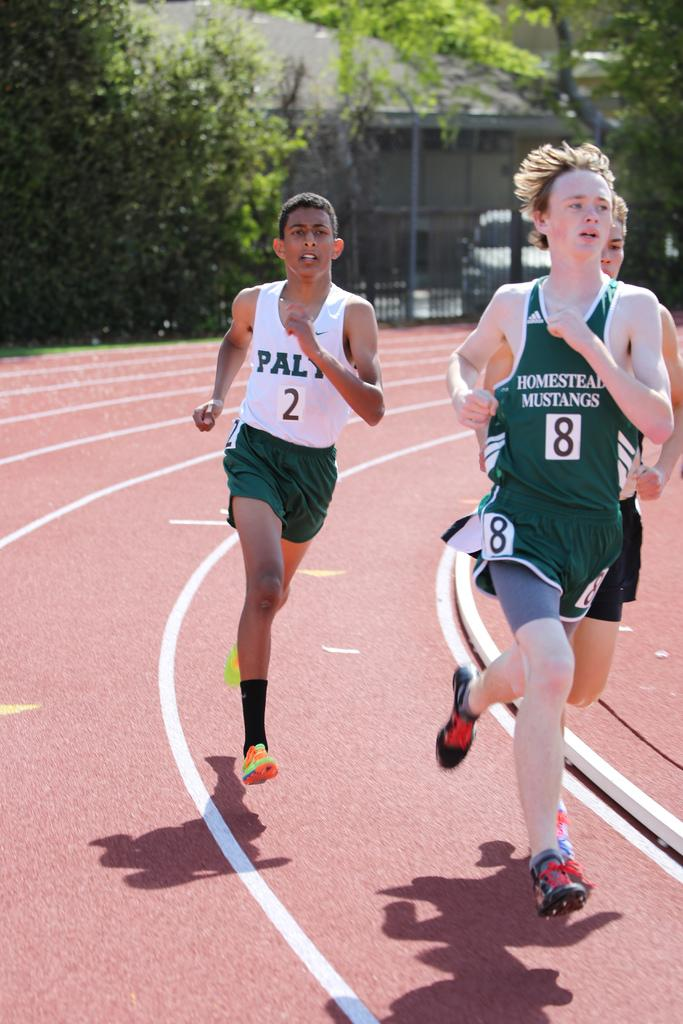<image>
Summarize the visual content of the image. number 8 in green jersey is running in the front 